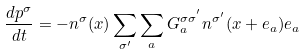<formula> <loc_0><loc_0><loc_500><loc_500>\frac { d { p } ^ { \sigma } } { d t } = - n ^ { \sigma } ( { x } ) \sum _ { \sigma ^ { \prime } } \sum _ { a } G ^ { \sigma \sigma ^ { ^ { \prime } } } _ { a } n ^ { \sigma ^ { \prime } } ( { x } + { e } _ { a } ) { e } _ { a }</formula> 